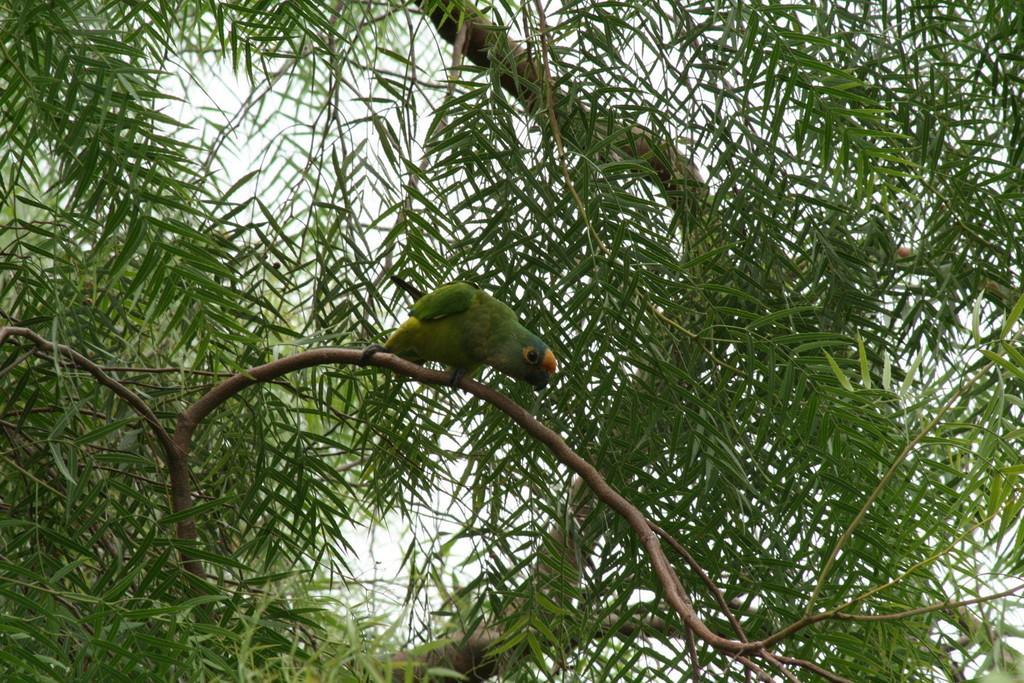How would you summarize this image in a sentence or two? In this image I can see the bird sitting on the branch of the tree. The bird is in green color. In the background I can see trees and the sky. 